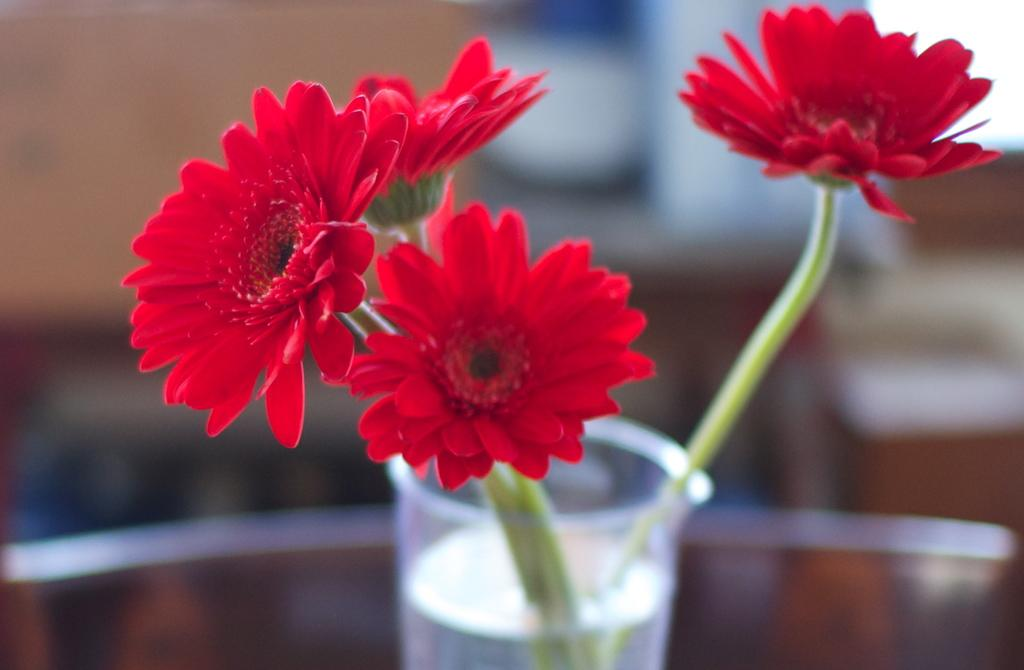What type of flowers are in the image? There are red color flowers in the image. How are the flowers displayed in the image? The flowers are in a glass of water. Can you describe the background of the image? The background of the image is blurred. What type of soda is being poured into the glass of water in the image? There is no soda present in the image; it features red color flowers in a glass of water. What type of motion is occurring with the flowers in the image? The flowers are stationary in the image; there is no motion. 